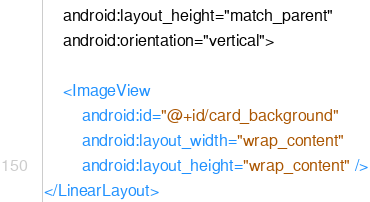Convert code to text. <code><loc_0><loc_0><loc_500><loc_500><_XML_>    android:layout_height="match_parent"
    android:orientation="vertical">

    <ImageView
        android:id="@+id/card_background"
        android:layout_width="wrap_content"
        android:layout_height="wrap_content" />
</LinearLayout></code> 